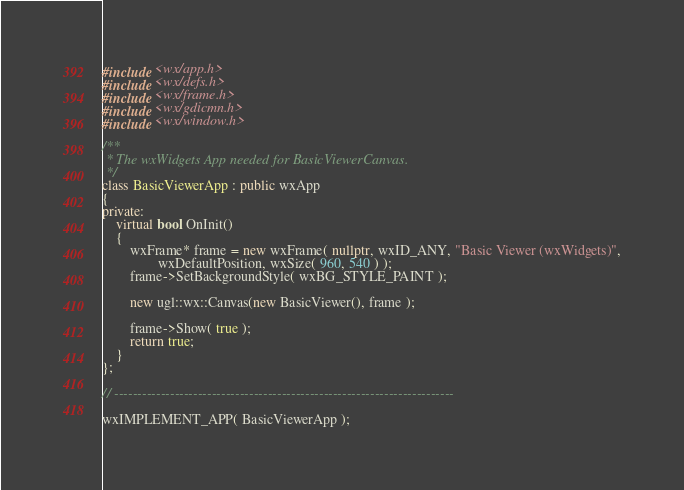Convert code to text. <code><loc_0><loc_0><loc_500><loc_500><_C++_>#include <wx/app.h>
#include <wx/defs.h>
#include <wx/frame.h>
#include <wx/gdicmn.h>
#include <wx/window.h>

/**
 * The wxWidgets App needed for BasicViewerCanvas.
 */
class BasicViewerApp : public wxApp
{
private:
    virtual bool OnInit()
    {
        wxFrame* frame = new wxFrame( nullptr, wxID_ANY, "Basic Viewer (wxWidgets)",
                wxDefaultPosition, wxSize( 960, 540 ) );
        frame->SetBackgroundStyle( wxBG_STYLE_PAINT );

        new ugl::wx::Canvas(new BasicViewer(), frame );

        frame->Show( true );
        return true;
    }
};

// -------------------------------------------------------------------------

wxIMPLEMENT_APP( BasicViewerApp );
</code> 